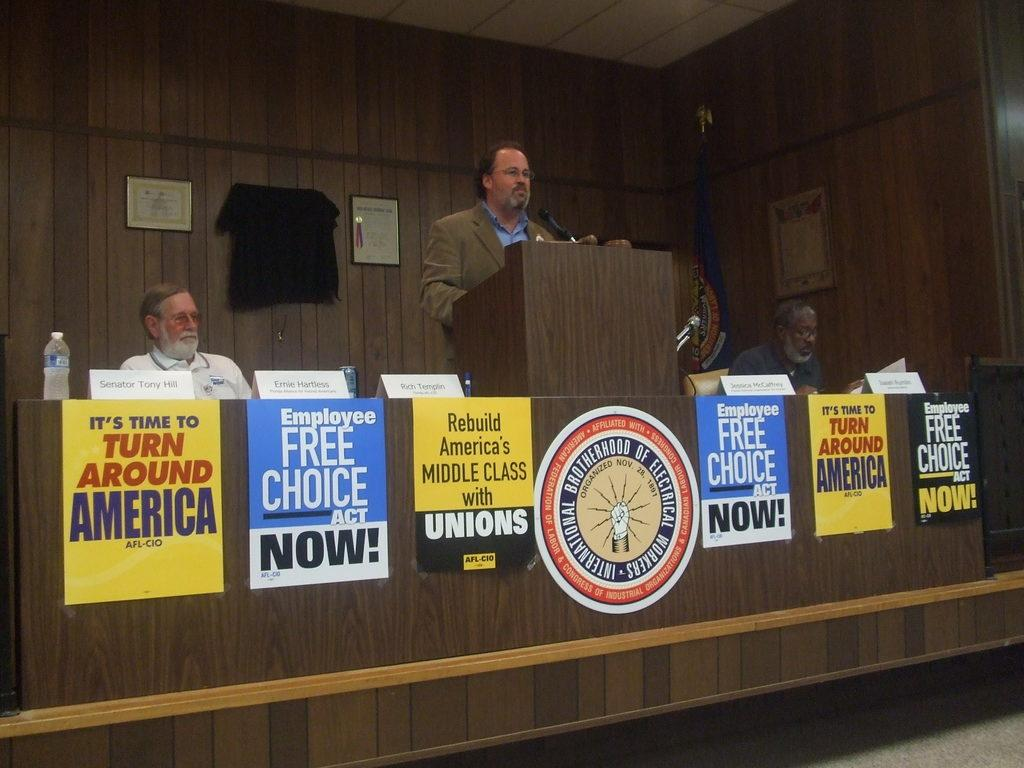<image>
Write a terse but informative summary of the picture. Campaign posters line a podium where a man speaks at the International Electrician's Brotherhood. 